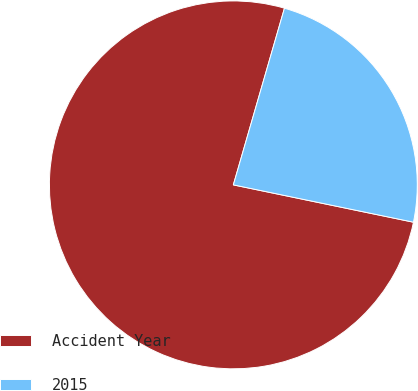Convert chart. <chart><loc_0><loc_0><loc_500><loc_500><pie_chart><fcel>Accident Year<fcel>2015<nl><fcel>76.23%<fcel>23.77%<nl></chart> 